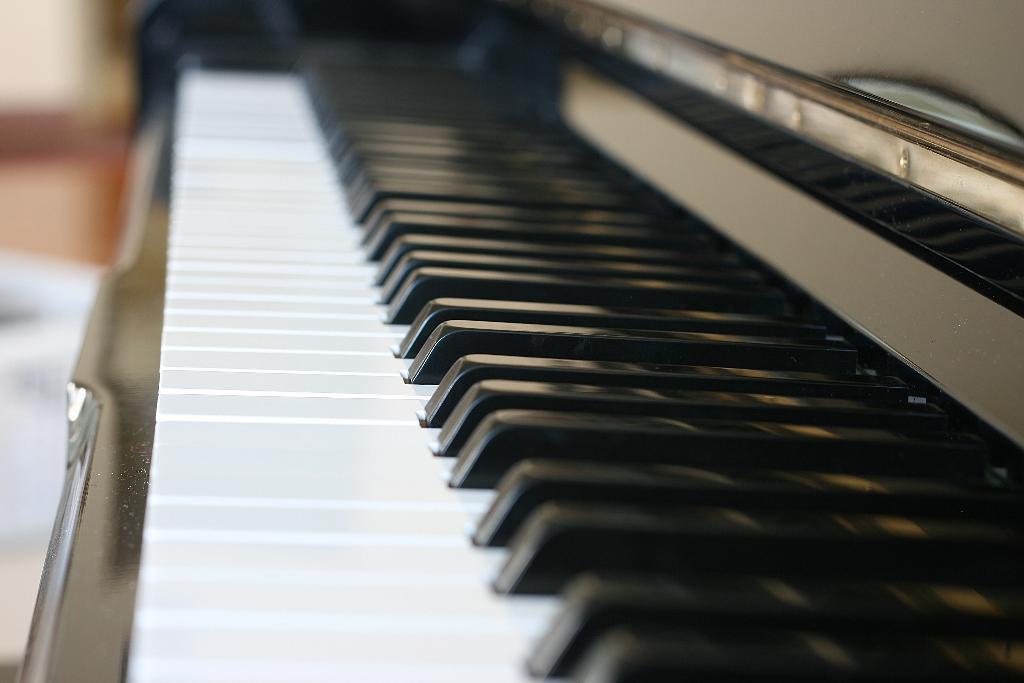Could you give a brief overview of what you see in this image? As we can see in the image there is a black and white color musical keyboard. 